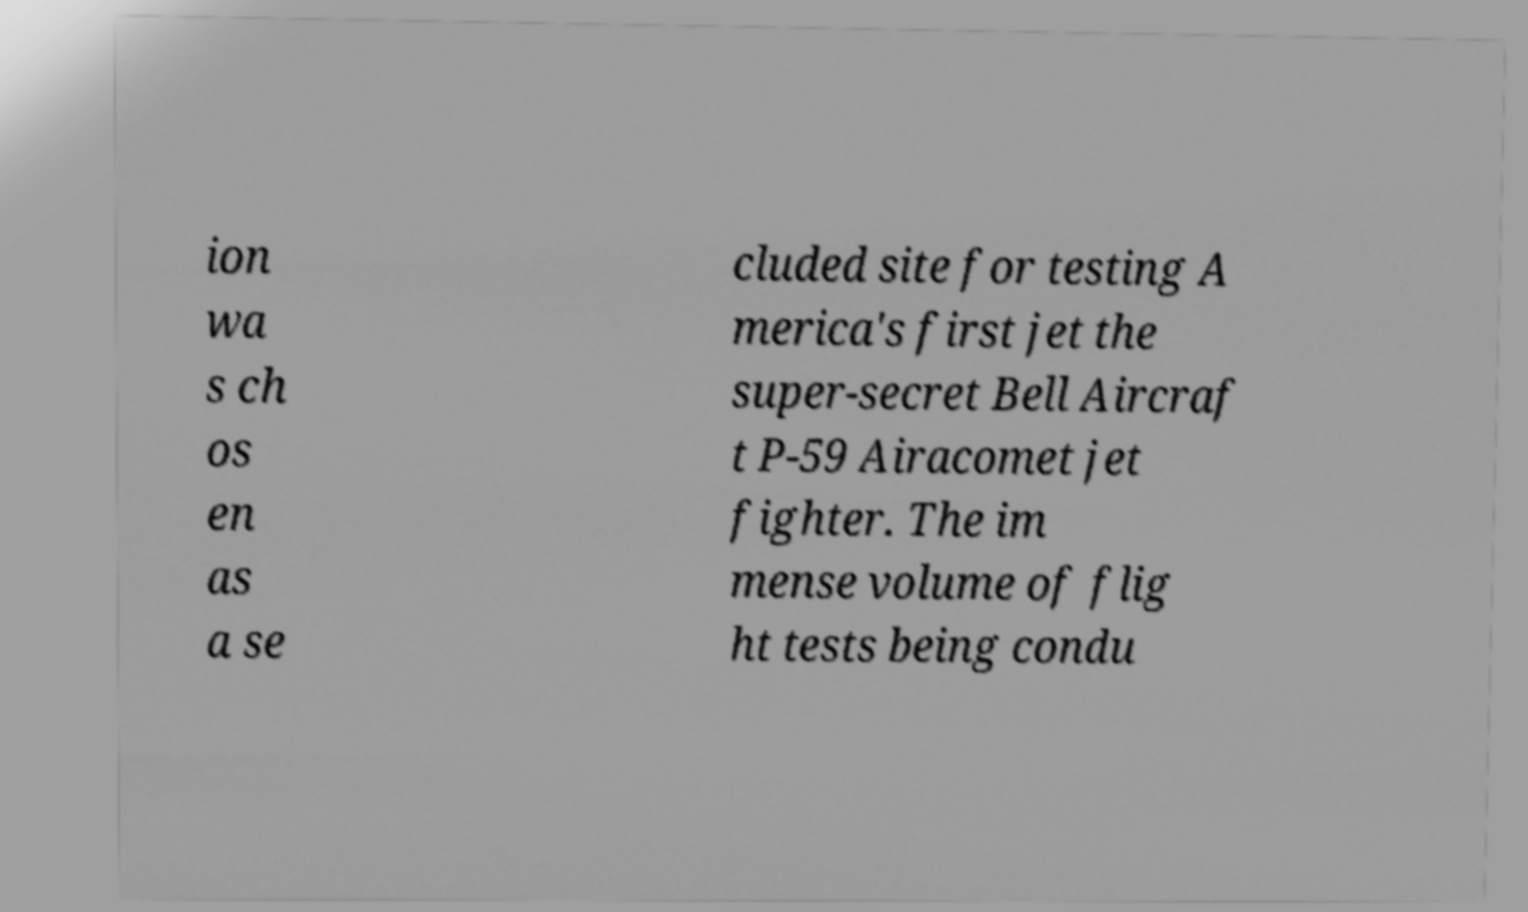Could you extract and type out the text from this image? ion wa s ch os en as a se cluded site for testing A merica's first jet the super-secret Bell Aircraf t P-59 Airacomet jet fighter. The im mense volume of flig ht tests being condu 